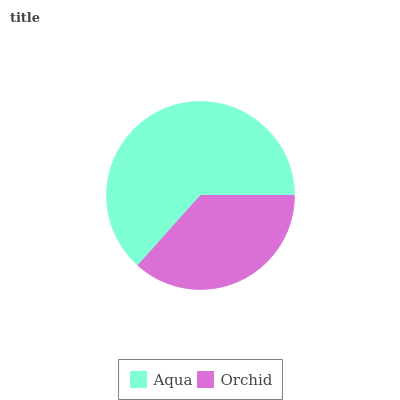Is Orchid the minimum?
Answer yes or no. Yes. Is Aqua the maximum?
Answer yes or no. Yes. Is Orchid the maximum?
Answer yes or no. No. Is Aqua greater than Orchid?
Answer yes or no. Yes. Is Orchid less than Aqua?
Answer yes or no. Yes. Is Orchid greater than Aqua?
Answer yes or no. No. Is Aqua less than Orchid?
Answer yes or no. No. Is Aqua the high median?
Answer yes or no. Yes. Is Orchid the low median?
Answer yes or no. Yes. Is Orchid the high median?
Answer yes or no. No. Is Aqua the low median?
Answer yes or no. No. 